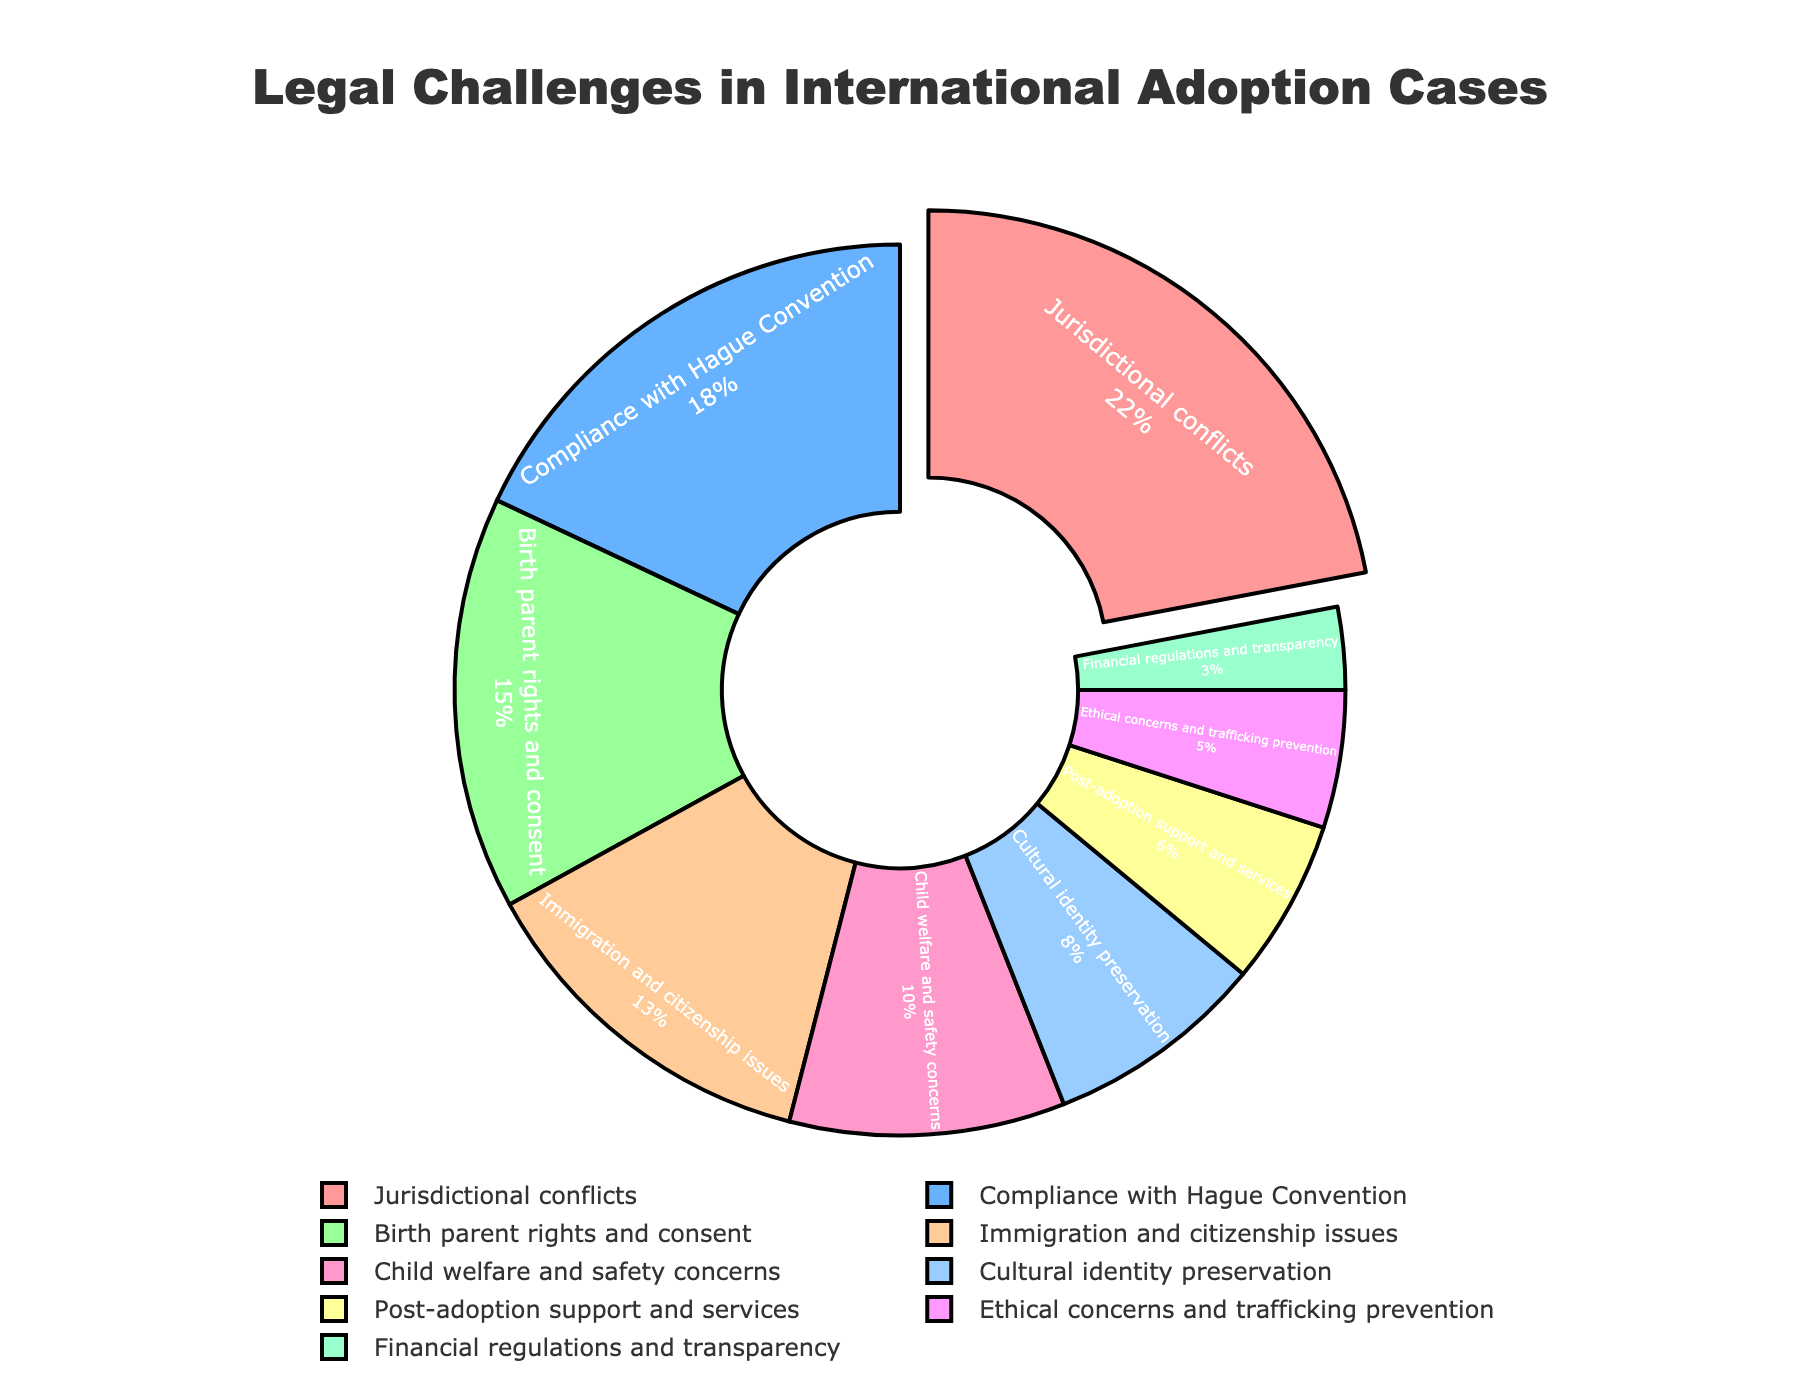What percentage of legal challenges are related to birth parent rights and consent? Birth parent rights and consent show a segment labeled as 15% on the pie chart.
Answer: 15% Which category has the largest percentage of legal challenges, and what is the percentage? The segment labeled "Jurisdictional conflicts" appears largest and is marked as 22%.
Answer: Jurisdictional conflicts, 22% Is the percentage for Compliance with Hague Convention higher or lower than for Cultural identity preservation? Compliance with Hague Convention has a percentage of 18%, whereas Cultural identity preservation has 8%. Since 18% is greater than 8%, Compliance with Hague Convention is higher.
Answer: Higher What is the sum of the percentages for Immigration and citizenship issues and Child welfare and safety concerns? Immigration and citizenship issues are 13% and Child welfare and safety concerns are 10%. Summing these percentages: 13% + 10% = 23%
Answer: 23% What is the difference in percentage between Financial regulations and transparency and Ethical concerns and trafficking prevention? Financial regulations and transparency represent 3%, and Ethical concerns and trafficking prevention represent 5%. The difference is 5% - 3% = 2%.
Answer: 2% How does the percentage of Post-adoption support and services compare to Child welfare and safety concerns? Post-adoption support and services is 6%, and Child welfare and safety concerns is 10%. Thus, 6% is less than 10%.
Answer: Less Rank the categories from highest to lowest percentage. Jurisdictional conflicts (22%), Compliance with Hague Convention (18%), Birth parent rights and consent (15%), Immigration and citizenship issues (13%), Child welfare and safety concerns (10%), Cultural identity preservation (8%), Post-adoption support and services (6%), Ethical concerns and trafficking prevention (5%), Financial regulations and transparency (3%).
Answer: Jurisdictional conflicts, Compliance with Hague Convention, Birth parent rights and consent, Immigration and citizenship issues, Child welfare and safety concerns, Cultural identity preservation, Post-adoption support and services, Ethical concerns and trafficking prevention, Financial regulations and transparency What is the combined percentage of the three smallest categories? The three smallest categories are Ethical concerns and trafficking prevention (5%), Financial regulations and transparency (3%), and Post-adoption support and services (6%). Adding these gives: 5% + 3% + 6% = 14%.
Answer: 14% Which segment of the pie chart is highlighted or pulled out slightly, and what is its percentage? The segment for Jurisdictional conflicts is pulled out slightly and has a percentage of 22%.
Answer: Jurisdictional conflicts, 22% 